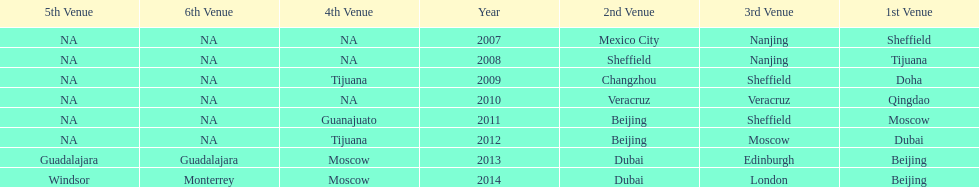Which two venue has no nations from 2007-2012 5th Venue, 6th Venue. 